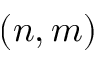Convert formula to latex. <formula><loc_0><loc_0><loc_500><loc_500>( n , m )</formula> 